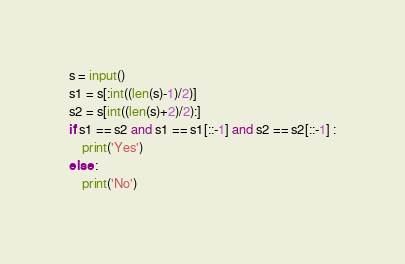<code> <loc_0><loc_0><loc_500><loc_500><_Python_>s = input()
s1 = s[:int((len(s)-1)/2)]
s2 = s[int((len(s)+2)/2):]
if s1 == s2 and s1 == s1[::-1] and s2 == s2[::-1] :
    print('Yes')
else :
    print('No')</code> 